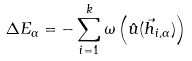Convert formula to latex. <formula><loc_0><loc_0><loc_500><loc_500>\Delta E _ { \alpha } = - \sum _ { i = 1 } ^ { k } \omega \left ( \hat { u } ( \vec { h } _ { i , \alpha } ) \right )</formula> 